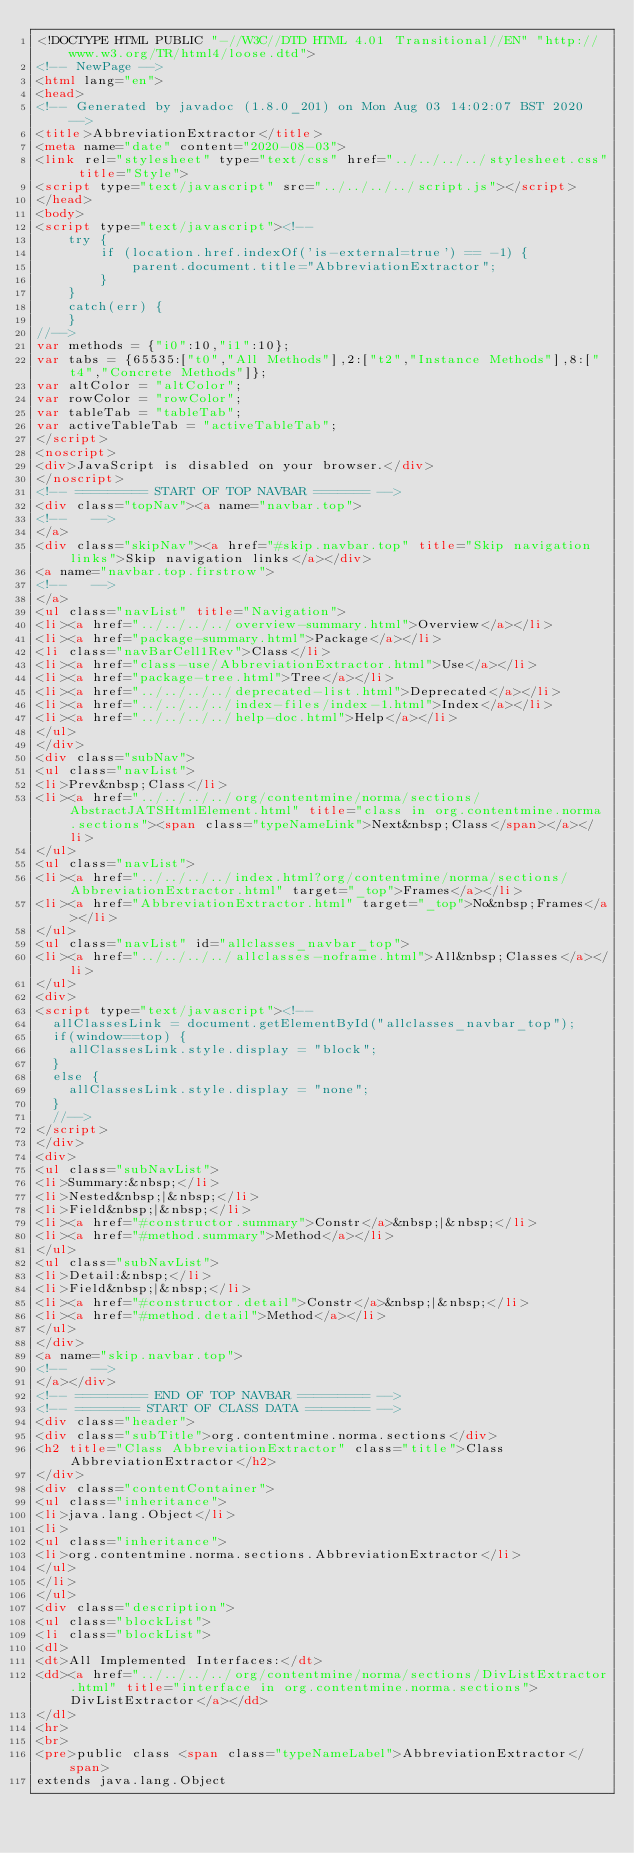<code> <loc_0><loc_0><loc_500><loc_500><_HTML_><!DOCTYPE HTML PUBLIC "-//W3C//DTD HTML 4.01 Transitional//EN" "http://www.w3.org/TR/html4/loose.dtd">
<!-- NewPage -->
<html lang="en">
<head>
<!-- Generated by javadoc (1.8.0_201) on Mon Aug 03 14:02:07 BST 2020 -->
<title>AbbreviationExtractor</title>
<meta name="date" content="2020-08-03">
<link rel="stylesheet" type="text/css" href="../../../../stylesheet.css" title="Style">
<script type="text/javascript" src="../../../../script.js"></script>
</head>
<body>
<script type="text/javascript"><!--
    try {
        if (location.href.indexOf('is-external=true') == -1) {
            parent.document.title="AbbreviationExtractor";
        }
    }
    catch(err) {
    }
//-->
var methods = {"i0":10,"i1":10};
var tabs = {65535:["t0","All Methods"],2:["t2","Instance Methods"],8:["t4","Concrete Methods"]};
var altColor = "altColor";
var rowColor = "rowColor";
var tableTab = "tableTab";
var activeTableTab = "activeTableTab";
</script>
<noscript>
<div>JavaScript is disabled on your browser.</div>
</noscript>
<!-- ========= START OF TOP NAVBAR ======= -->
<div class="topNav"><a name="navbar.top">
<!--   -->
</a>
<div class="skipNav"><a href="#skip.navbar.top" title="Skip navigation links">Skip navigation links</a></div>
<a name="navbar.top.firstrow">
<!--   -->
</a>
<ul class="navList" title="Navigation">
<li><a href="../../../../overview-summary.html">Overview</a></li>
<li><a href="package-summary.html">Package</a></li>
<li class="navBarCell1Rev">Class</li>
<li><a href="class-use/AbbreviationExtractor.html">Use</a></li>
<li><a href="package-tree.html">Tree</a></li>
<li><a href="../../../../deprecated-list.html">Deprecated</a></li>
<li><a href="../../../../index-files/index-1.html">Index</a></li>
<li><a href="../../../../help-doc.html">Help</a></li>
</ul>
</div>
<div class="subNav">
<ul class="navList">
<li>Prev&nbsp;Class</li>
<li><a href="../../../../org/contentmine/norma/sections/AbstractJATSHtmlElement.html" title="class in org.contentmine.norma.sections"><span class="typeNameLink">Next&nbsp;Class</span></a></li>
</ul>
<ul class="navList">
<li><a href="../../../../index.html?org/contentmine/norma/sections/AbbreviationExtractor.html" target="_top">Frames</a></li>
<li><a href="AbbreviationExtractor.html" target="_top">No&nbsp;Frames</a></li>
</ul>
<ul class="navList" id="allclasses_navbar_top">
<li><a href="../../../../allclasses-noframe.html">All&nbsp;Classes</a></li>
</ul>
<div>
<script type="text/javascript"><!--
  allClassesLink = document.getElementById("allclasses_navbar_top");
  if(window==top) {
    allClassesLink.style.display = "block";
  }
  else {
    allClassesLink.style.display = "none";
  }
  //-->
</script>
</div>
<div>
<ul class="subNavList">
<li>Summary:&nbsp;</li>
<li>Nested&nbsp;|&nbsp;</li>
<li>Field&nbsp;|&nbsp;</li>
<li><a href="#constructor.summary">Constr</a>&nbsp;|&nbsp;</li>
<li><a href="#method.summary">Method</a></li>
</ul>
<ul class="subNavList">
<li>Detail:&nbsp;</li>
<li>Field&nbsp;|&nbsp;</li>
<li><a href="#constructor.detail">Constr</a>&nbsp;|&nbsp;</li>
<li><a href="#method.detail">Method</a></li>
</ul>
</div>
<a name="skip.navbar.top">
<!--   -->
</a></div>
<!-- ========= END OF TOP NAVBAR ========= -->
<!-- ======== START OF CLASS DATA ======== -->
<div class="header">
<div class="subTitle">org.contentmine.norma.sections</div>
<h2 title="Class AbbreviationExtractor" class="title">Class AbbreviationExtractor</h2>
</div>
<div class="contentContainer">
<ul class="inheritance">
<li>java.lang.Object</li>
<li>
<ul class="inheritance">
<li>org.contentmine.norma.sections.AbbreviationExtractor</li>
</ul>
</li>
</ul>
<div class="description">
<ul class="blockList">
<li class="blockList">
<dl>
<dt>All Implemented Interfaces:</dt>
<dd><a href="../../../../org/contentmine/norma/sections/DivListExtractor.html" title="interface in org.contentmine.norma.sections">DivListExtractor</a></dd>
</dl>
<hr>
<br>
<pre>public class <span class="typeNameLabel">AbbreviationExtractor</span>
extends java.lang.Object</code> 